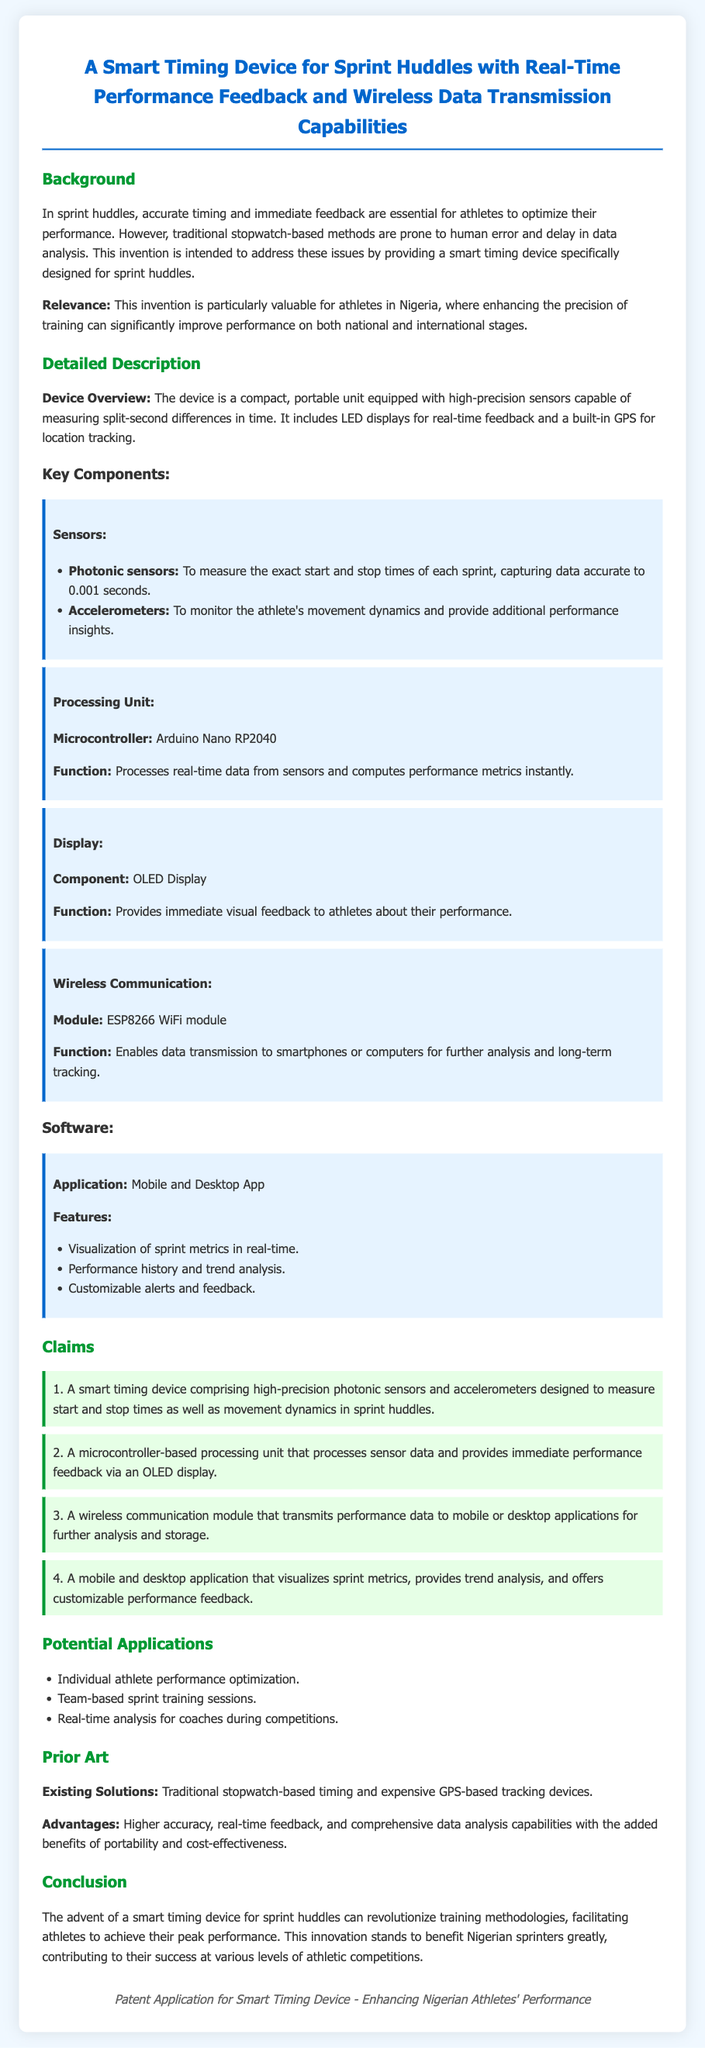What is the main purpose of the smart timing device? The main purpose is to provide accurate timing and immediate feedback for athletes in sprint huddles.
Answer: Accurate timing and immediate feedback What type of sensors does the device use? The device uses photonic sensors and accelerometers for measurement and performance insights.
Answer: Photonic sensors and accelerometers What microcontroller is mentioned in the document? The document specifically mentions the Arduino Nano RP2040 as the microcontroller used in the device.
Answer: Arduino Nano RP2040 What is a key advantage of this device compared to traditional methods? The key advantage is higher accuracy and real-time feedback for performance analysis.
Answer: Higher accuracy and real-time feedback How can performance data be transmitted from the device? Performance data can be transmitted via a wireless communication module, specifically the ESP8266 WiFi module.
Answer: ESP8266 WiFi module What type of applications does the device support? The device supports a mobile and desktop application for visualization and analysis of sprint metrics.
Answer: Mobile and desktop application What is the accuracy of the timing measured by the device? The device captures timing data accurate to 0.001 seconds.
Answer: 0.001 seconds Who is the target audience for this invention? The primary target audience for this invention is athletes in Nigeria.
Answer: Athletes in Nigeria 